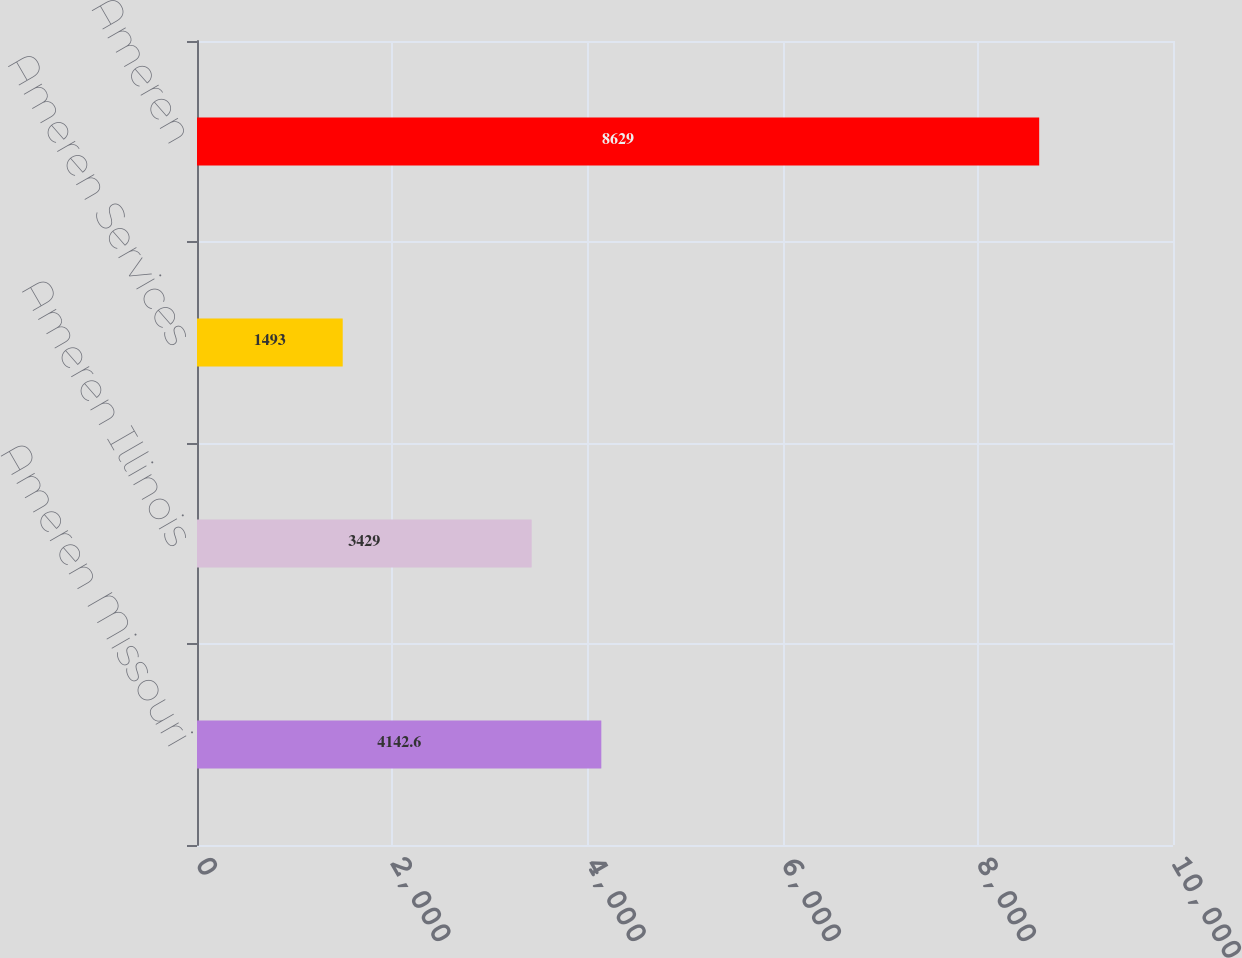Convert chart. <chart><loc_0><loc_0><loc_500><loc_500><bar_chart><fcel>Ameren Missouri<fcel>Ameren Illinois<fcel>Ameren Services<fcel>Ameren<nl><fcel>4142.6<fcel>3429<fcel>1493<fcel>8629<nl></chart> 